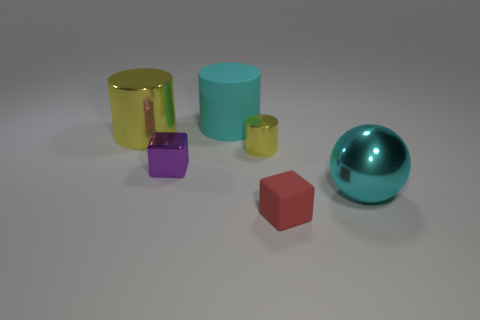There is a cube that is behind the red cube; is it the same size as the small red cube?
Your response must be concise. Yes. What number of big cylinders are to the left of the tiny metallic block?
Your response must be concise. 1. Is there a purple metallic thing of the same size as the cyan matte thing?
Your response must be concise. No. Do the matte block and the small metallic cube have the same color?
Provide a short and direct response. No. The matte thing that is in front of the rubber thing left of the matte cube is what color?
Your response must be concise. Red. How many things are behind the red cube and left of the cyan metallic object?
Your answer should be very brief. 4. How many other matte things are the same shape as the tiny rubber object?
Ensure brevity in your answer.  0. Are the red block and the purple thing made of the same material?
Keep it short and to the point. No. What shape is the matte thing that is in front of the large thing in front of the shiny block?
Provide a succinct answer. Cube. There is a big yellow cylinder left of the tiny yellow metal cylinder; what number of large cyan objects are behind it?
Keep it short and to the point. 1. 